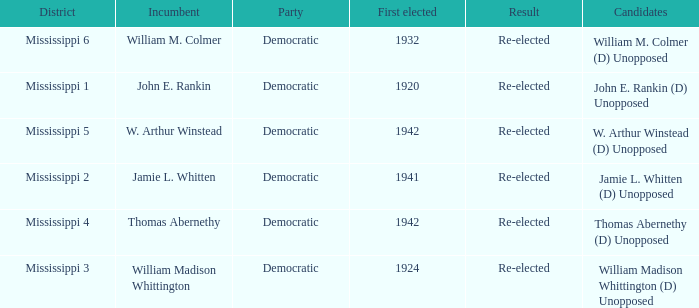What is the result for w. arthur winstead? Re-elected. 